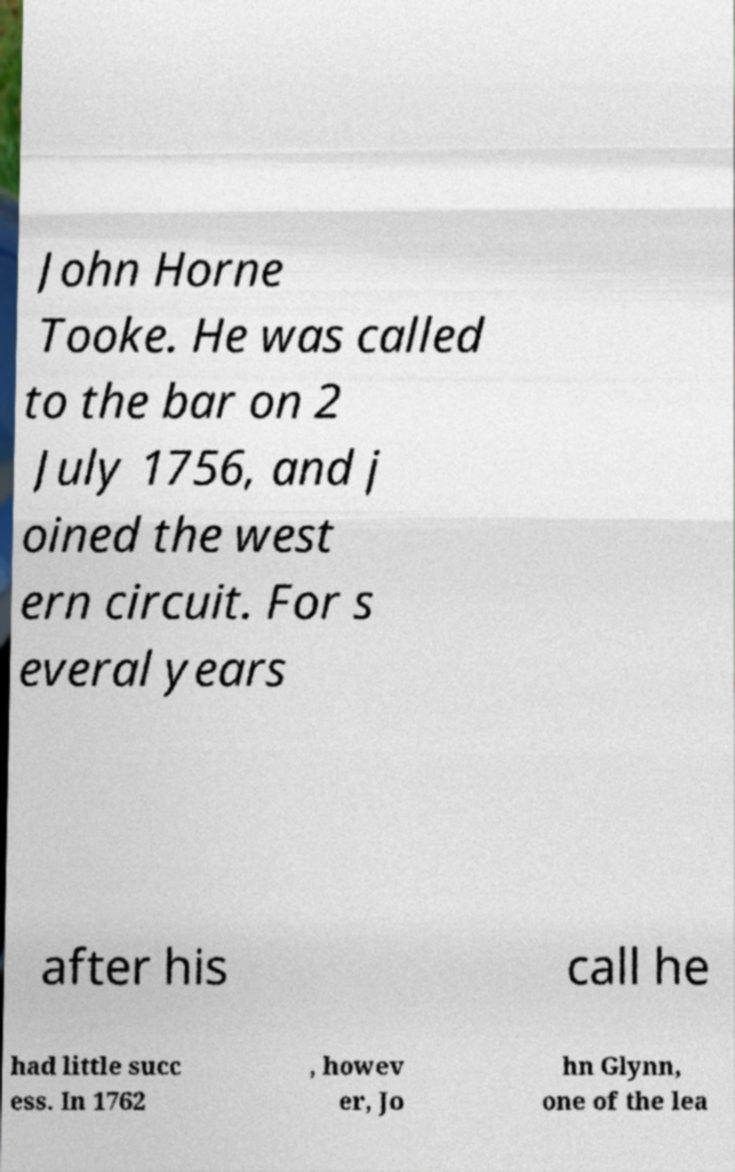I need the written content from this picture converted into text. Can you do that? John Horne Tooke. He was called to the bar on 2 July 1756, and j oined the west ern circuit. For s everal years after his call he had little succ ess. In 1762 , howev er, Jo hn Glynn, one of the lea 